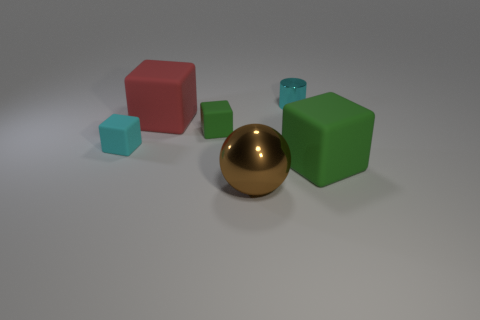Add 3 tiny cyan cylinders. How many objects exist? 9 Subtract all cubes. How many objects are left? 2 Subtract 0 cyan spheres. How many objects are left? 6 Subtract all small cyan shiny things. Subtract all large green cubes. How many objects are left? 4 Add 6 cyan things. How many cyan things are left? 8 Add 1 small green rubber blocks. How many small green rubber blocks exist? 2 